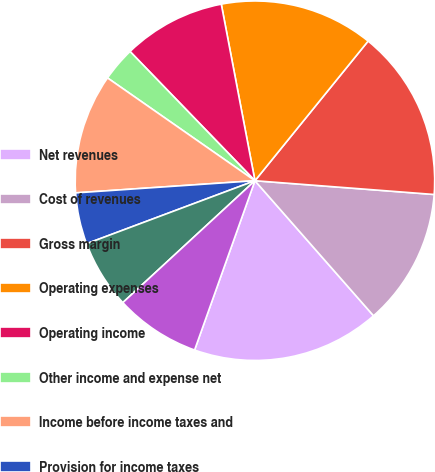<chart> <loc_0><loc_0><loc_500><loc_500><pie_chart><fcel>Net revenues<fcel>Cost of revenues<fcel>Gross margin<fcel>Operating expenses<fcel>Operating income<fcel>Other income and expense net<fcel>Income before income taxes and<fcel>Provision for income taxes<fcel>Consolidated net income<fcel>Net income attributable to<nl><fcel>16.92%<fcel>12.31%<fcel>15.38%<fcel>13.84%<fcel>9.23%<fcel>3.08%<fcel>10.77%<fcel>4.62%<fcel>6.16%<fcel>7.69%<nl></chart> 